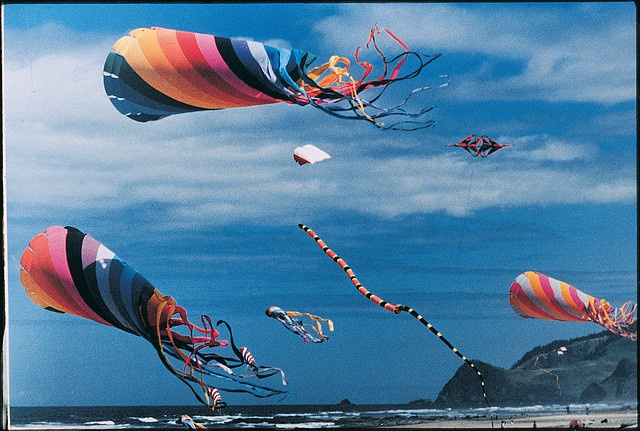Describe the objects in this image and their specific colors. I can see kite in black, teal, blue, and salmon tones, kite in black, teal, maroon, and salmon tones, kite in black, gray, maroon, brown, and orange tones, kite in black, teal, gray, and salmon tones, and kite in black, teal, darkgray, and gray tones in this image. 